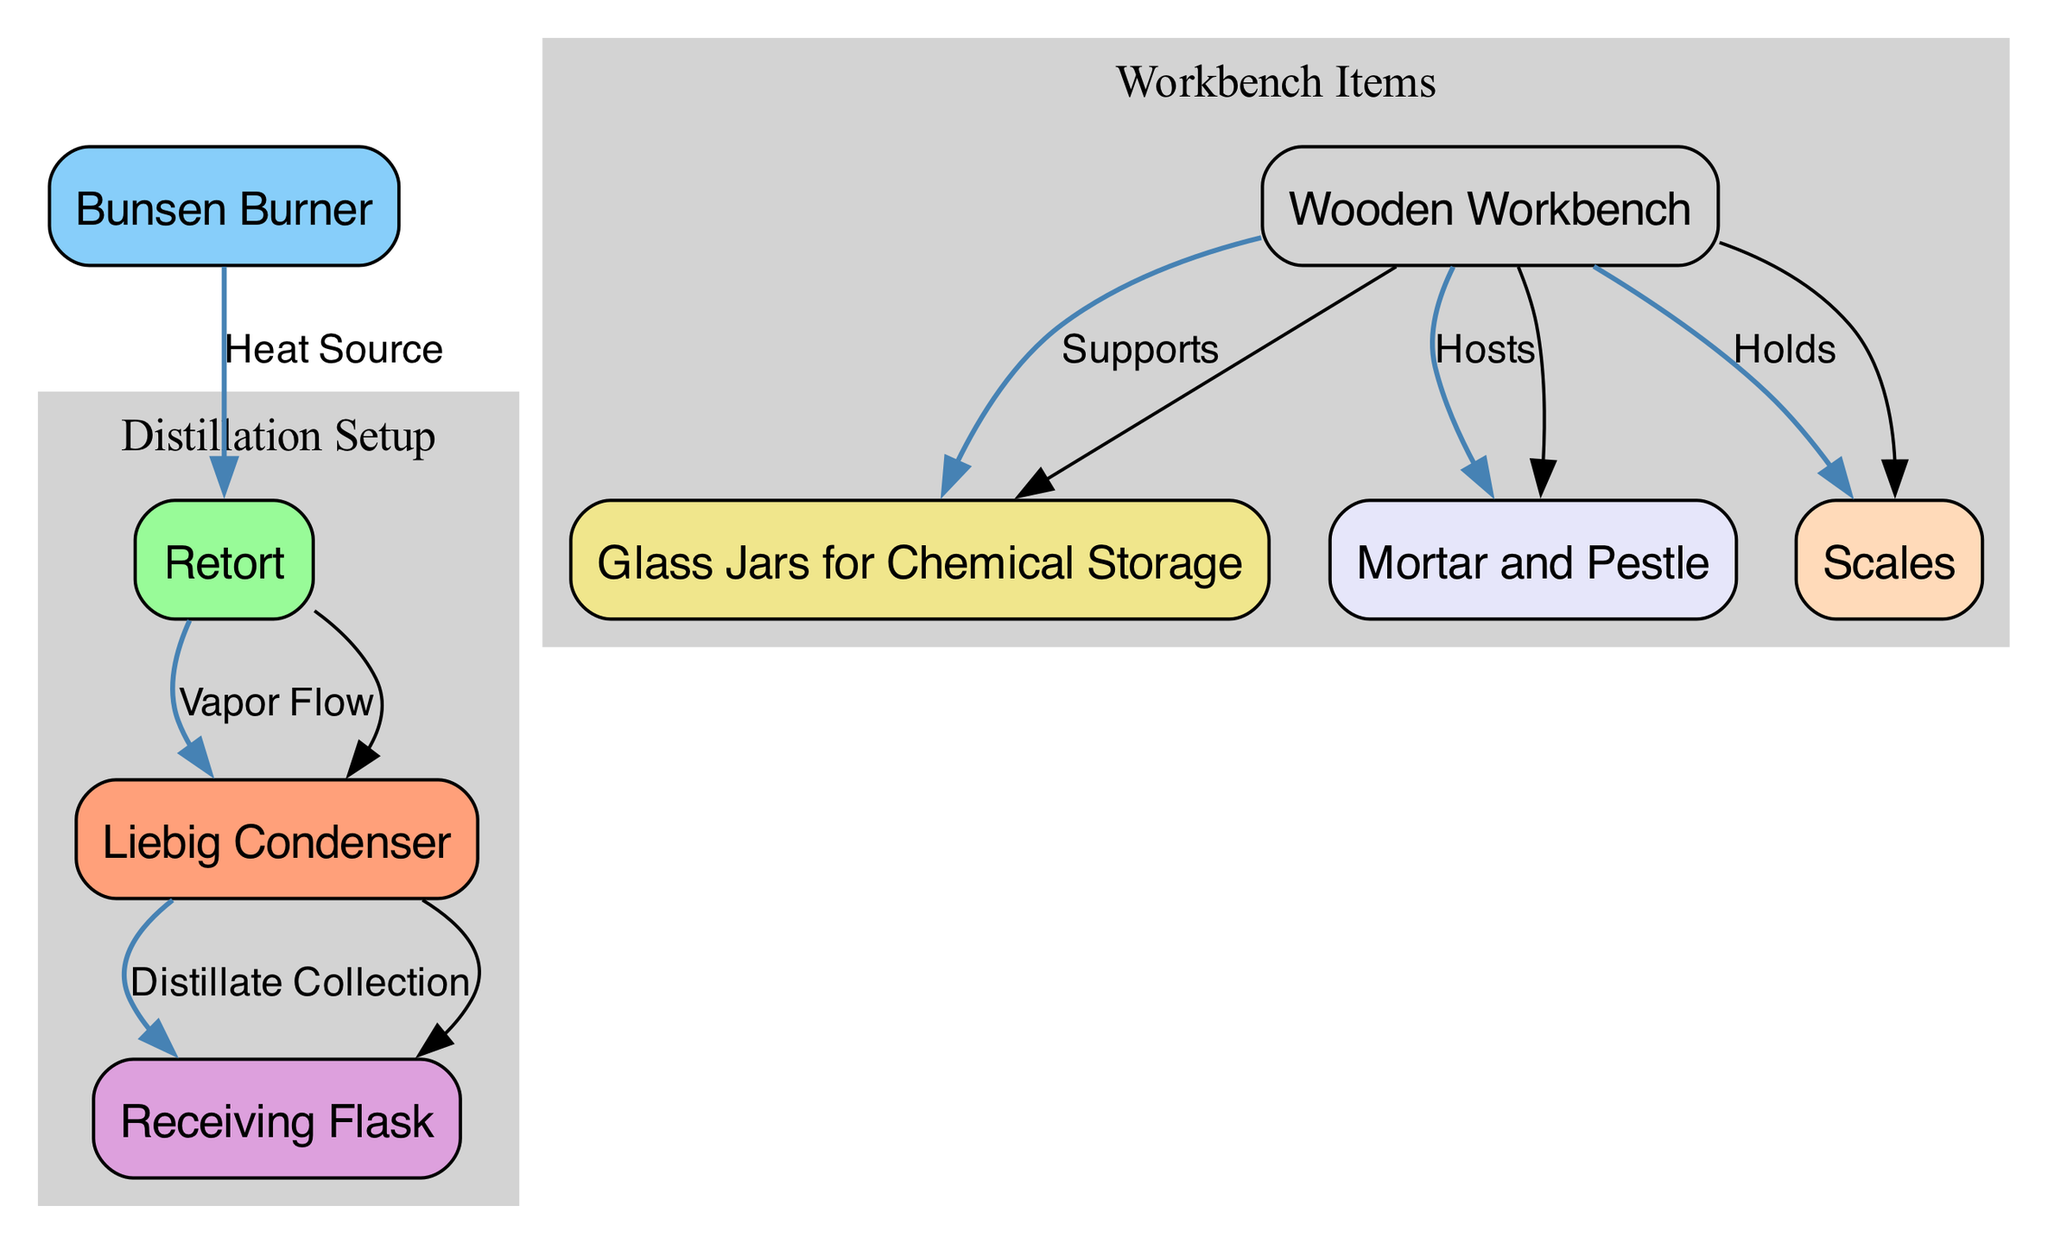What is the total number of nodes in the diagram? The diagram lists 8 nodes representing different components of the pharmaceutical laboratory setup. Counting these nodes directly provides the total: Liebig Condenser, Retort, Bunsen Burner, Receiving Flask, Glass Jars for Chemical Storage, Mortar and Pestle, Scales, and Wooden Workbench.
Answer: 8 Which node does the 'Heat Source' edge originate from? The 'Heat Source' edge is defined in the diagram starting from the Bunsen Burner (node 3) and flows to the Retort (node 2). Therefore, the edge originates from the Bunsen Burner.
Answer: Bunsen Burner How many edges are depicted in the diagram? By analyzing the edges listed, there are 5 edges connecting the nodes. These represent various relationships, such as vapor flow, distillate collection, and support between components. Count the edges directly to find the total.
Answer: 5 What is the function of the Liebig Condenser in the setup? The Liebig Condenser is used to collect distillate from the vapor generated in the distillation process. It connects to the Retort where vapor from a heated substance flows into it, leading to distillate collection into the Receiving Flask.
Answer: Distillate Collection Which items are supported by the Wooden Workbench? The diagram indicates that the Wooden Workbench (node 8) supports three items: Glass Jars for Chemical Storage (node 5), Mortar and Pestle (node 6), and Scales (node 7). The edges drawn from the Workbench to these items illustrate this relationship.
Answer: Glass Jars for Chemical Storage, Mortar and Pestle, Scales What is the direction of the 'Vapor Flow'? The 'Vapor Flow' edge in the diagram is directed from the Retort (node 2) to the Liebig Condenser (node 1). Following the flow indicated by the arrow helps determine the direction of the vapor.
Answer: Retort to Liebig Condenser Which node is connected to the Receiving Flask? The Receiving Flask (node 4) is directly connected to the Liebig Condenser (node 1), indicating the collection process of the distillate flowing from the condenser to the flask. The edge labeled 'Distillate Collection' shows this relationship.
Answer: Liebig Condenser What does the Mortar and Pestle connect to in the diagram? The Mortar and Pestle (node 6) is indicated as being hosted by the Wooden Workbench (node 8) in the diagram. Observing the edge labeled 'Hosts' shows this connection clearly.
Answer: Wooden Workbench 